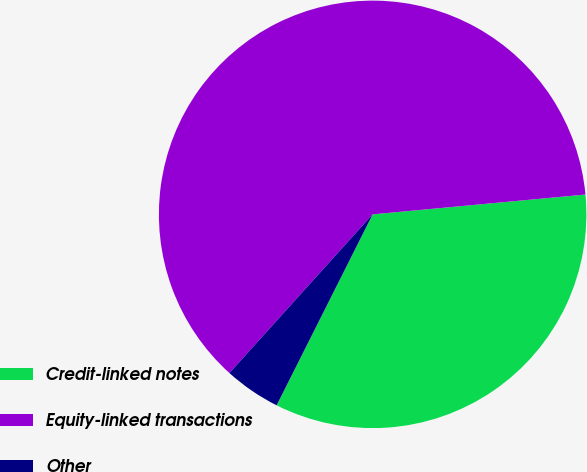Convert chart. <chart><loc_0><loc_0><loc_500><loc_500><pie_chart><fcel>Credit-linked notes<fcel>Equity-linked transactions<fcel>Other<nl><fcel>33.89%<fcel>61.83%<fcel>4.27%<nl></chart> 